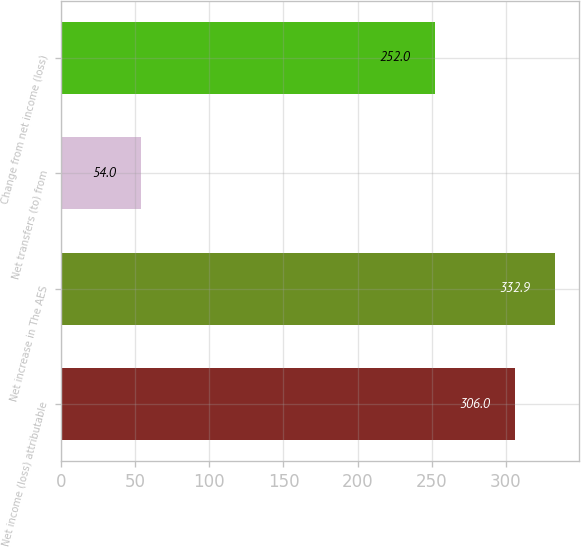Convert chart to OTSL. <chart><loc_0><loc_0><loc_500><loc_500><bar_chart><fcel>Net income (loss) attributable<fcel>Net increase in The AES<fcel>Net transfers (to) from<fcel>Change from net income (loss)<nl><fcel>306<fcel>332.9<fcel>54<fcel>252<nl></chart> 